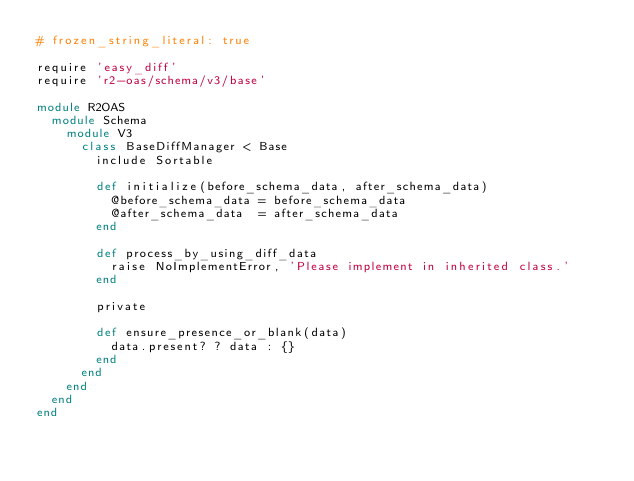<code> <loc_0><loc_0><loc_500><loc_500><_Ruby_># frozen_string_literal: true

require 'easy_diff'
require 'r2-oas/schema/v3/base'

module R2OAS
  module Schema
    module V3
      class BaseDiffManager < Base
        include Sortable

        def initialize(before_schema_data, after_schema_data)
          @before_schema_data = before_schema_data
          @after_schema_data  = after_schema_data
        end

        def process_by_using_diff_data
          raise NoImplementError, 'Please implement in inherited class.'
        end

        private

        def ensure_presence_or_blank(data)
          data.present? ? data : {}
        end
      end
    end
  end
end
</code> 